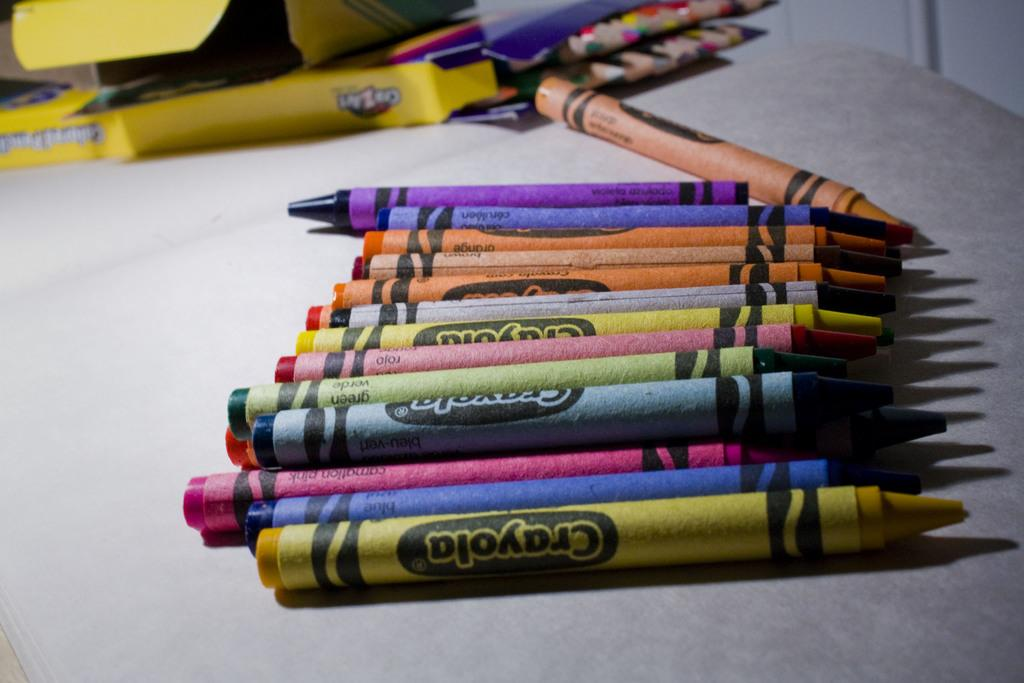<image>
Describe the image concisely. Several different color Crayola crayons on a table next to the box they came from and also a box of colored pencils. 